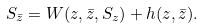<formula> <loc_0><loc_0><loc_500><loc_500>S _ { \bar { z } } = W ( z , \bar { z } , S _ { z } ) + h ( z , \bar { z } ) .</formula> 